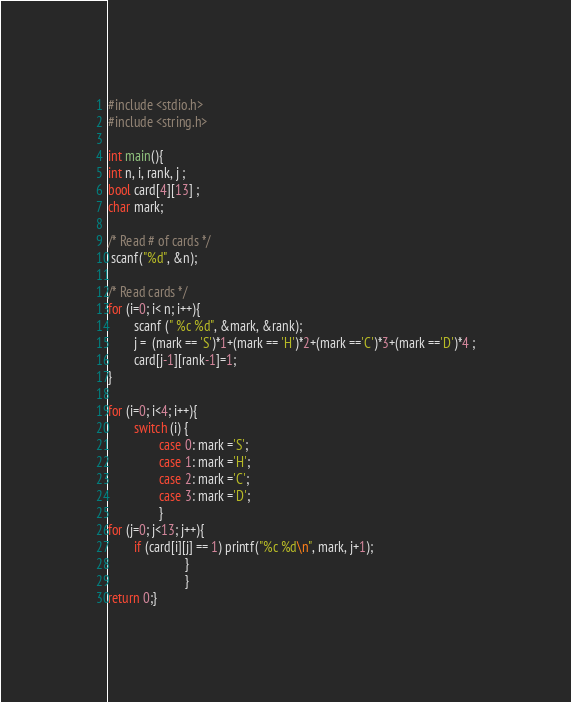<code> <loc_0><loc_0><loc_500><loc_500><_C_>#include <stdio.h>
#include <string.h>

int main(){
int n, i, rank, j ;
bool card[4][13] ;
char mark;

/* Read # of cards */
 scanf("%d", &n);

/* Read cards */
for (i=0; i< n; i++){
        scanf (" %c %d", &mark, &rank);
        j =  (mark == 'S')*1+(mark == 'H')*2+(mark =='C')*3+(mark =='D')*4 ;
        card[j-1][rank-1]=1;
}

for (i=0; i<4; i++){
        switch (i) {
                case 0: mark ='S';
                case 1: mark ='H';
                case 2: mark ='C';
                case 3: mark ='D';
                }
for (j=0; j<13; j++){
        if (card[i][j] == 1) printf("%c %d\n", mark, j+1);
                        }
                        }
return 0;}</code> 